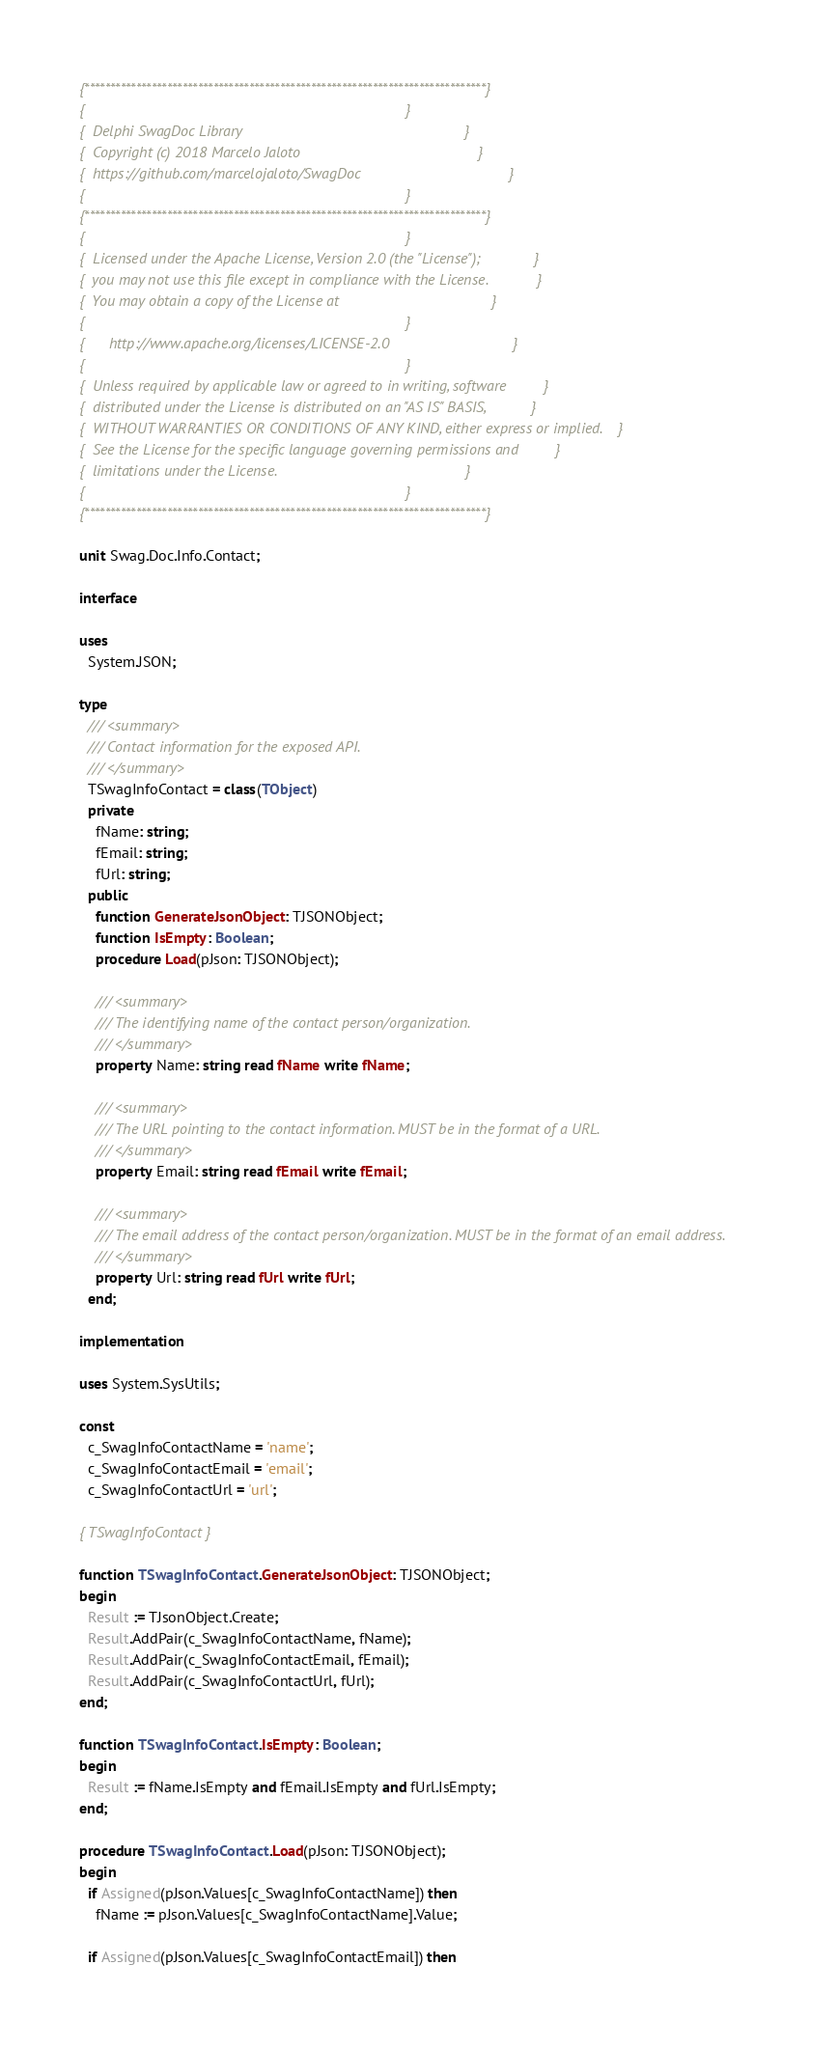<code> <loc_0><loc_0><loc_500><loc_500><_Pascal_>{******************************************************************************}
{                                                                              }
{  Delphi SwagDoc Library                                                      }
{  Copyright (c) 2018 Marcelo Jaloto                                           }
{  https://github.com/marcelojaloto/SwagDoc                                    }
{                                                                              }
{******************************************************************************}
{                                                                              }
{  Licensed under the Apache License, Version 2.0 (the "License");             }
{  you may not use this file except in compliance with the License.            }
{  You may obtain a copy of the License at                                     }
{                                                                              }
{      http://www.apache.org/licenses/LICENSE-2.0                              }
{                                                                              }
{  Unless required by applicable law or agreed to in writing, software         }
{  distributed under the License is distributed on an "AS IS" BASIS,           }
{  WITHOUT WARRANTIES OR CONDITIONS OF ANY KIND, either express or implied.    }
{  See the License for the specific language governing permissions and         }
{  limitations under the License.                                              }
{                                                                              }
{******************************************************************************}

unit Swag.Doc.Info.Contact;

interface

uses
  System.JSON;

type
  /// <summary>
  /// Contact information for the exposed API.
  /// </summary>
  TSwagInfoContact = class(TObject)
  private
    fName: string;
    fEmail: string;
    fUrl: string;
  public
    function GenerateJsonObject: TJSONObject;
    function IsEmpty: Boolean;
    procedure Load(pJson: TJSONObject);

    /// <summary>
    /// The identifying name of the contact person/organization.
    /// </summary>
    property Name: string read fName write fName;

    /// <summary>
    /// The URL pointing to the contact information. MUST be in the format of a URL.
    /// </summary>
    property Email: string read fEmail write fEmail;

    /// <summary>
    /// The email address of the contact person/organization. MUST be in the format of an email address.
    /// </summary>
    property Url: string read fUrl write fUrl;
  end;

implementation

uses System.SysUtils;

const
  c_SwagInfoContactName = 'name';
  c_SwagInfoContactEmail = 'email';
  c_SwagInfoContactUrl = 'url';

{ TSwagInfoContact }

function TSwagInfoContact.GenerateJsonObject: TJSONObject;
begin
  Result := TJsonObject.Create;
  Result.AddPair(c_SwagInfoContactName, fName);
  Result.AddPair(c_SwagInfoContactEmail, fEmail);
  Result.AddPair(c_SwagInfoContactUrl, fUrl);
end;

function TSwagInfoContact.IsEmpty: Boolean;
begin
  Result := fName.IsEmpty and fEmail.IsEmpty and fUrl.IsEmpty;
end;

procedure TSwagInfoContact.Load(pJson: TJSONObject);
begin
  if Assigned(pJson.Values[c_SwagInfoContactName]) then
    fName := pJson.Values[c_SwagInfoContactName].Value;

  if Assigned(pJson.Values[c_SwagInfoContactEmail]) then</code> 